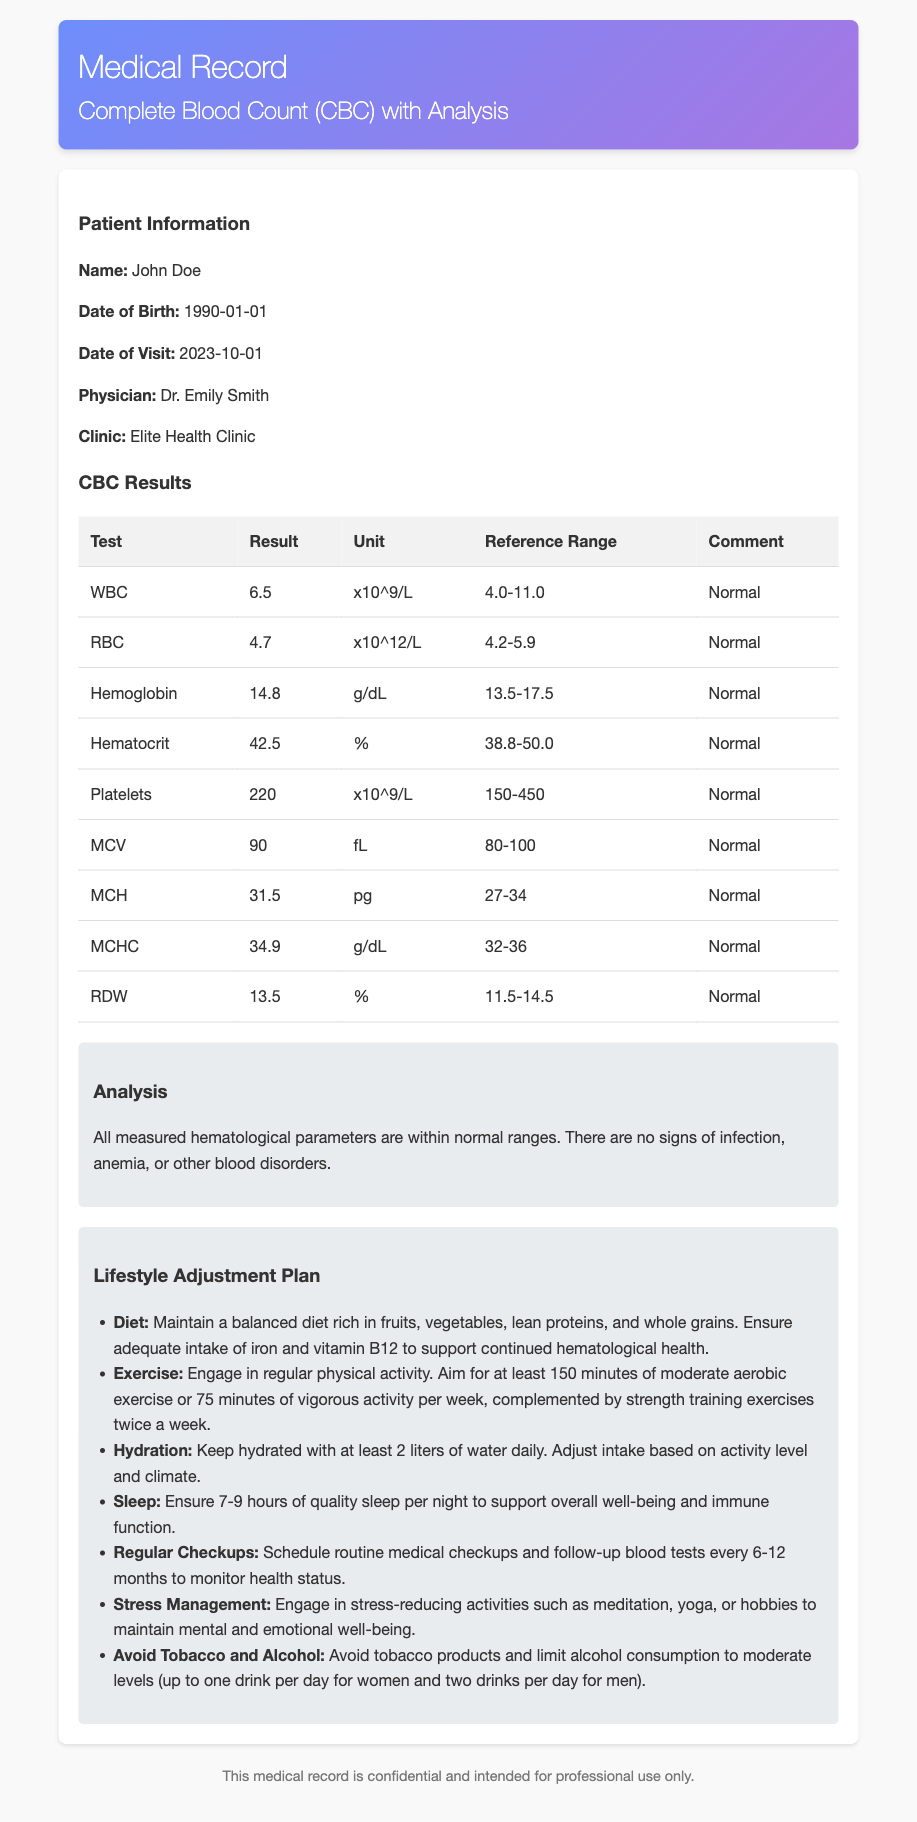what is the name of the patient? The patient's name is provided in the patient information section of the document.
Answer: John Doe what is the date of the visit? The date of the visit is recorded in the patient information section of the document.
Answer: 2023-10-01 who is the physician? The physician's name is mentioned in the patient information section of the document.
Answer: Dr. Emily Smith what is the result for Hemoglobin? The result for Hemoglobin is specified in the CBC results table.
Answer: 14.8 what is the reference range for RDW? The reference range for RDW can be found in the CBC results table.
Answer: 11.5-14.5 what lifestyle adjustment is recommended for hydration? The lifestyle adjustment plan details recommendations for hydration.
Answer: Keep hydrated with at least 2 liters of water daily how many minutes of moderate exercise are recommended weekly? The lifestyle adjustment plan specifies the duration of recommended physical activity.
Answer: 150 minutes what is stated in the analysis section concerning the hematological parameters? The analysis section gives insights about the hematological parameters from the CBC results.
Answer: All measured hematological parameters are within normal ranges what should be avoided according to the lifestyle adjustment plan? The lifestyle adjustment plan advises on substances to avoid for optimal health.
Answer: Tobacco and Alcohol 